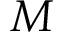<formula> <loc_0><loc_0><loc_500><loc_500>M</formula> 